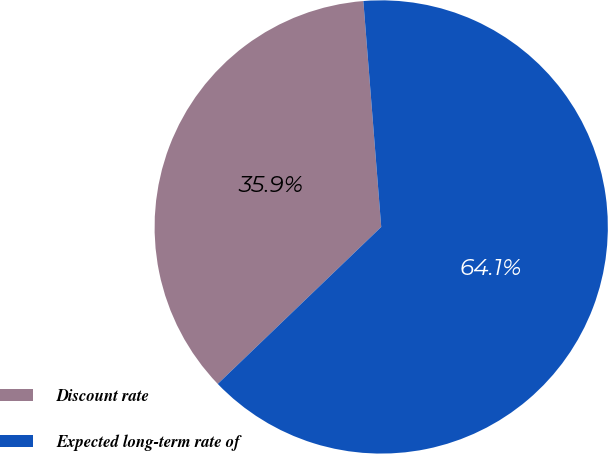Convert chart. <chart><loc_0><loc_0><loc_500><loc_500><pie_chart><fcel>Discount rate<fcel>Expected long-term rate of<nl><fcel>35.92%<fcel>64.08%<nl></chart> 